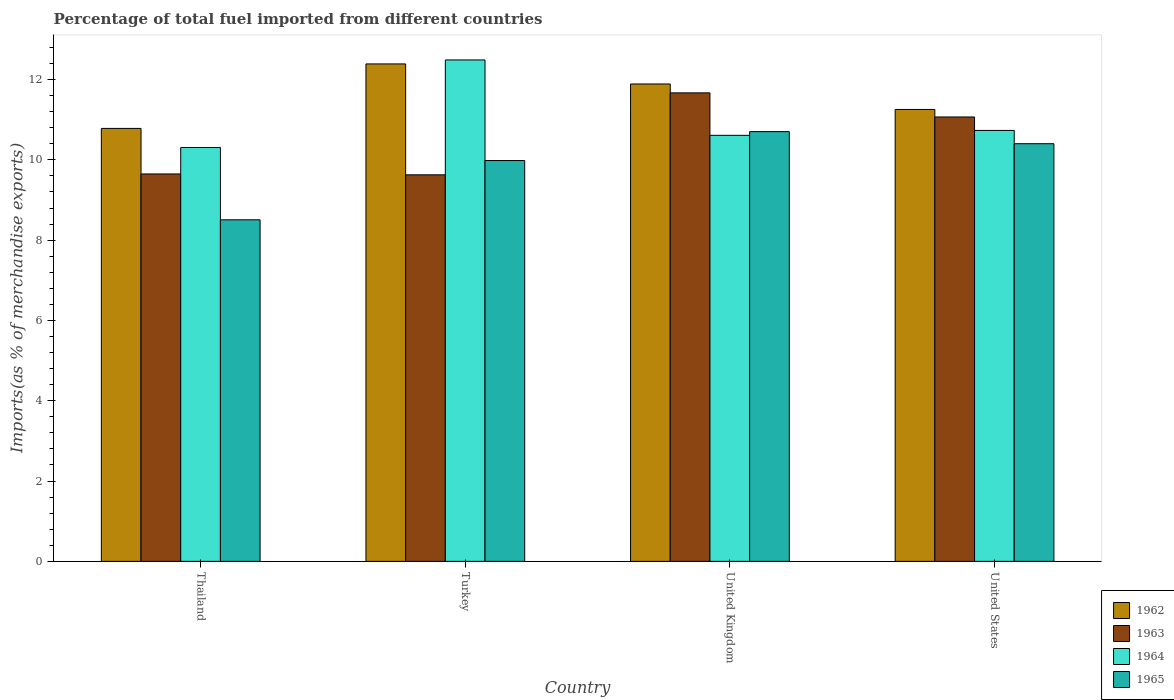How many different coloured bars are there?
Offer a terse response. 4. How many groups of bars are there?
Provide a succinct answer. 4. Are the number of bars on each tick of the X-axis equal?
Provide a succinct answer. Yes. How many bars are there on the 3rd tick from the right?
Offer a very short reply. 4. What is the label of the 1st group of bars from the left?
Keep it short and to the point. Thailand. In how many cases, is the number of bars for a given country not equal to the number of legend labels?
Provide a short and direct response. 0. What is the percentage of imports to different countries in 1965 in Turkey?
Offer a terse response. 9.98. Across all countries, what is the maximum percentage of imports to different countries in 1963?
Your answer should be compact. 11.67. Across all countries, what is the minimum percentage of imports to different countries in 1963?
Your answer should be very brief. 9.63. In which country was the percentage of imports to different countries in 1963 maximum?
Your answer should be compact. United Kingdom. In which country was the percentage of imports to different countries in 1963 minimum?
Your answer should be very brief. Turkey. What is the total percentage of imports to different countries in 1964 in the graph?
Your answer should be very brief. 44.14. What is the difference between the percentage of imports to different countries in 1965 in United Kingdom and that in United States?
Provide a short and direct response. 0.3. What is the difference between the percentage of imports to different countries in 1964 in United Kingdom and the percentage of imports to different countries in 1962 in United States?
Offer a terse response. -0.64. What is the average percentage of imports to different countries in 1964 per country?
Your answer should be very brief. 11.03. What is the difference between the percentage of imports to different countries of/in 1965 and percentage of imports to different countries of/in 1963 in United States?
Give a very brief answer. -0.67. In how many countries, is the percentage of imports to different countries in 1965 greater than 11.6 %?
Ensure brevity in your answer.  0. What is the ratio of the percentage of imports to different countries in 1964 in Thailand to that in United Kingdom?
Offer a very short reply. 0.97. Is the percentage of imports to different countries in 1965 in Thailand less than that in United States?
Ensure brevity in your answer.  Yes. Is the difference between the percentage of imports to different countries in 1965 in Thailand and Turkey greater than the difference between the percentage of imports to different countries in 1963 in Thailand and Turkey?
Give a very brief answer. No. What is the difference between the highest and the second highest percentage of imports to different countries in 1963?
Give a very brief answer. 1.42. What is the difference between the highest and the lowest percentage of imports to different countries in 1964?
Ensure brevity in your answer.  2.18. Is the sum of the percentage of imports to different countries in 1962 in United Kingdom and United States greater than the maximum percentage of imports to different countries in 1964 across all countries?
Offer a terse response. Yes. What does the 2nd bar from the right in United States represents?
Make the answer very short. 1964. Is it the case that in every country, the sum of the percentage of imports to different countries in 1964 and percentage of imports to different countries in 1963 is greater than the percentage of imports to different countries in 1965?
Keep it short and to the point. Yes. Are all the bars in the graph horizontal?
Make the answer very short. No. What is the difference between two consecutive major ticks on the Y-axis?
Your answer should be compact. 2. Are the values on the major ticks of Y-axis written in scientific E-notation?
Your answer should be compact. No. Where does the legend appear in the graph?
Provide a short and direct response. Bottom right. What is the title of the graph?
Your answer should be very brief. Percentage of total fuel imported from different countries. What is the label or title of the Y-axis?
Offer a terse response. Imports(as % of merchandise exports). What is the Imports(as % of merchandise exports) in 1962 in Thailand?
Offer a terse response. 10.78. What is the Imports(as % of merchandise exports) of 1963 in Thailand?
Your answer should be very brief. 9.65. What is the Imports(as % of merchandise exports) in 1964 in Thailand?
Give a very brief answer. 10.31. What is the Imports(as % of merchandise exports) in 1965 in Thailand?
Keep it short and to the point. 8.51. What is the Imports(as % of merchandise exports) in 1962 in Turkey?
Provide a short and direct response. 12.39. What is the Imports(as % of merchandise exports) in 1963 in Turkey?
Offer a very short reply. 9.63. What is the Imports(as % of merchandise exports) of 1964 in Turkey?
Your response must be concise. 12.49. What is the Imports(as % of merchandise exports) in 1965 in Turkey?
Provide a short and direct response. 9.98. What is the Imports(as % of merchandise exports) in 1962 in United Kingdom?
Offer a terse response. 11.89. What is the Imports(as % of merchandise exports) in 1963 in United Kingdom?
Offer a very short reply. 11.67. What is the Imports(as % of merchandise exports) in 1964 in United Kingdom?
Offer a terse response. 10.61. What is the Imports(as % of merchandise exports) in 1965 in United Kingdom?
Your answer should be very brief. 10.7. What is the Imports(as % of merchandise exports) in 1962 in United States?
Your answer should be very brief. 11.25. What is the Imports(as % of merchandise exports) of 1963 in United States?
Provide a succinct answer. 11.07. What is the Imports(as % of merchandise exports) in 1964 in United States?
Offer a very short reply. 10.73. What is the Imports(as % of merchandise exports) in 1965 in United States?
Your answer should be very brief. 10.4. Across all countries, what is the maximum Imports(as % of merchandise exports) of 1962?
Give a very brief answer. 12.39. Across all countries, what is the maximum Imports(as % of merchandise exports) of 1963?
Provide a succinct answer. 11.67. Across all countries, what is the maximum Imports(as % of merchandise exports) in 1964?
Your response must be concise. 12.49. Across all countries, what is the maximum Imports(as % of merchandise exports) in 1965?
Ensure brevity in your answer.  10.7. Across all countries, what is the minimum Imports(as % of merchandise exports) of 1962?
Offer a very short reply. 10.78. Across all countries, what is the minimum Imports(as % of merchandise exports) in 1963?
Keep it short and to the point. 9.63. Across all countries, what is the minimum Imports(as % of merchandise exports) of 1964?
Your answer should be compact. 10.31. Across all countries, what is the minimum Imports(as % of merchandise exports) of 1965?
Keep it short and to the point. 8.51. What is the total Imports(as % of merchandise exports) of 1962 in the graph?
Provide a succinct answer. 46.31. What is the total Imports(as % of merchandise exports) in 1963 in the graph?
Offer a very short reply. 42.01. What is the total Imports(as % of merchandise exports) of 1964 in the graph?
Provide a succinct answer. 44.14. What is the total Imports(as % of merchandise exports) of 1965 in the graph?
Keep it short and to the point. 39.59. What is the difference between the Imports(as % of merchandise exports) in 1962 in Thailand and that in Turkey?
Offer a terse response. -1.61. What is the difference between the Imports(as % of merchandise exports) of 1963 in Thailand and that in Turkey?
Offer a terse response. 0.02. What is the difference between the Imports(as % of merchandise exports) in 1964 in Thailand and that in Turkey?
Give a very brief answer. -2.18. What is the difference between the Imports(as % of merchandise exports) in 1965 in Thailand and that in Turkey?
Provide a short and direct response. -1.48. What is the difference between the Imports(as % of merchandise exports) of 1962 in Thailand and that in United Kingdom?
Your answer should be compact. -1.11. What is the difference between the Imports(as % of merchandise exports) of 1963 in Thailand and that in United Kingdom?
Provide a short and direct response. -2.02. What is the difference between the Imports(as % of merchandise exports) of 1964 in Thailand and that in United Kingdom?
Ensure brevity in your answer.  -0.3. What is the difference between the Imports(as % of merchandise exports) in 1965 in Thailand and that in United Kingdom?
Ensure brevity in your answer.  -2.2. What is the difference between the Imports(as % of merchandise exports) in 1962 in Thailand and that in United States?
Your answer should be very brief. -0.47. What is the difference between the Imports(as % of merchandise exports) of 1963 in Thailand and that in United States?
Provide a succinct answer. -1.42. What is the difference between the Imports(as % of merchandise exports) of 1964 in Thailand and that in United States?
Offer a terse response. -0.42. What is the difference between the Imports(as % of merchandise exports) in 1965 in Thailand and that in United States?
Your answer should be compact. -1.9. What is the difference between the Imports(as % of merchandise exports) of 1962 in Turkey and that in United Kingdom?
Provide a succinct answer. 0.5. What is the difference between the Imports(as % of merchandise exports) in 1963 in Turkey and that in United Kingdom?
Ensure brevity in your answer.  -2.04. What is the difference between the Imports(as % of merchandise exports) in 1964 in Turkey and that in United Kingdom?
Provide a short and direct response. 1.88. What is the difference between the Imports(as % of merchandise exports) of 1965 in Turkey and that in United Kingdom?
Offer a very short reply. -0.72. What is the difference between the Imports(as % of merchandise exports) of 1962 in Turkey and that in United States?
Offer a terse response. 1.13. What is the difference between the Imports(as % of merchandise exports) of 1963 in Turkey and that in United States?
Offer a terse response. -1.44. What is the difference between the Imports(as % of merchandise exports) in 1964 in Turkey and that in United States?
Provide a succinct answer. 1.76. What is the difference between the Imports(as % of merchandise exports) of 1965 in Turkey and that in United States?
Keep it short and to the point. -0.42. What is the difference between the Imports(as % of merchandise exports) of 1962 in United Kingdom and that in United States?
Ensure brevity in your answer.  0.63. What is the difference between the Imports(as % of merchandise exports) of 1963 in United Kingdom and that in United States?
Give a very brief answer. 0.6. What is the difference between the Imports(as % of merchandise exports) in 1964 in United Kingdom and that in United States?
Your response must be concise. -0.12. What is the difference between the Imports(as % of merchandise exports) in 1965 in United Kingdom and that in United States?
Keep it short and to the point. 0.3. What is the difference between the Imports(as % of merchandise exports) in 1962 in Thailand and the Imports(as % of merchandise exports) in 1963 in Turkey?
Offer a very short reply. 1.16. What is the difference between the Imports(as % of merchandise exports) in 1962 in Thailand and the Imports(as % of merchandise exports) in 1964 in Turkey?
Provide a short and direct response. -1.71. What is the difference between the Imports(as % of merchandise exports) in 1963 in Thailand and the Imports(as % of merchandise exports) in 1964 in Turkey?
Your response must be concise. -2.84. What is the difference between the Imports(as % of merchandise exports) in 1963 in Thailand and the Imports(as % of merchandise exports) in 1965 in Turkey?
Provide a succinct answer. -0.33. What is the difference between the Imports(as % of merchandise exports) in 1964 in Thailand and the Imports(as % of merchandise exports) in 1965 in Turkey?
Your answer should be very brief. 0.32. What is the difference between the Imports(as % of merchandise exports) in 1962 in Thailand and the Imports(as % of merchandise exports) in 1963 in United Kingdom?
Offer a terse response. -0.89. What is the difference between the Imports(as % of merchandise exports) of 1962 in Thailand and the Imports(as % of merchandise exports) of 1964 in United Kingdom?
Your answer should be compact. 0.17. What is the difference between the Imports(as % of merchandise exports) of 1962 in Thailand and the Imports(as % of merchandise exports) of 1965 in United Kingdom?
Make the answer very short. 0.08. What is the difference between the Imports(as % of merchandise exports) of 1963 in Thailand and the Imports(as % of merchandise exports) of 1964 in United Kingdom?
Offer a terse response. -0.96. What is the difference between the Imports(as % of merchandise exports) in 1963 in Thailand and the Imports(as % of merchandise exports) in 1965 in United Kingdom?
Your response must be concise. -1.05. What is the difference between the Imports(as % of merchandise exports) of 1964 in Thailand and the Imports(as % of merchandise exports) of 1965 in United Kingdom?
Your answer should be compact. -0.4. What is the difference between the Imports(as % of merchandise exports) of 1962 in Thailand and the Imports(as % of merchandise exports) of 1963 in United States?
Provide a succinct answer. -0.28. What is the difference between the Imports(as % of merchandise exports) of 1962 in Thailand and the Imports(as % of merchandise exports) of 1964 in United States?
Give a very brief answer. 0.05. What is the difference between the Imports(as % of merchandise exports) in 1962 in Thailand and the Imports(as % of merchandise exports) in 1965 in United States?
Keep it short and to the point. 0.38. What is the difference between the Imports(as % of merchandise exports) of 1963 in Thailand and the Imports(as % of merchandise exports) of 1964 in United States?
Offer a terse response. -1.08. What is the difference between the Imports(as % of merchandise exports) in 1963 in Thailand and the Imports(as % of merchandise exports) in 1965 in United States?
Keep it short and to the point. -0.75. What is the difference between the Imports(as % of merchandise exports) in 1964 in Thailand and the Imports(as % of merchandise exports) in 1965 in United States?
Your response must be concise. -0.09. What is the difference between the Imports(as % of merchandise exports) of 1962 in Turkey and the Imports(as % of merchandise exports) of 1963 in United Kingdom?
Your answer should be very brief. 0.72. What is the difference between the Imports(as % of merchandise exports) in 1962 in Turkey and the Imports(as % of merchandise exports) in 1964 in United Kingdom?
Your answer should be very brief. 1.78. What is the difference between the Imports(as % of merchandise exports) of 1962 in Turkey and the Imports(as % of merchandise exports) of 1965 in United Kingdom?
Provide a succinct answer. 1.69. What is the difference between the Imports(as % of merchandise exports) of 1963 in Turkey and the Imports(as % of merchandise exports) of 1964 in United Kingdom?
Provide a short and direct response. -0.98. What is the difference between the Imports(as % of merchandise exports) in 1963 in Turkey and the Imports(as % of merchandise exports) in 1965 in United Kingdom?
Offer a very short reply. -1.08. What is the difference between the Imports(as % of merchandise exports) in 1964 in Turkey and the Imports(as % of merchandise exports) in 1965 in United Kingdom?
Provide a succinct answer. 1.78. What is the difference between the Imports(as % of merchandise exports) of 1962 in Turkey and the Imports(as % of merchandise exports) of 1963 in United States?
Your answer should be compact. 1.32. What is the difference between the Imports(as % of merchandise exports) of 1962 in Turkey and the Imports(as % of merchandise exports) of 1964 in United States?
Ensure brevity in your answer.  1.66. What is the difference between the Imports(as % of merchandise exports) in 1962 in Turkey and the Imports(as % of merchandise exports) in 1965 in United States?
Make the answer very short. 1.99. What is the difference between the Imports(as % of merchandise exports) in 1963 in Turkey and the Imports(as % of merchandise exports) in 1964 in United States?
Your response must be concise. -1.11. What is the difference between the Imports(as % of merchandise exports) of 1963 in Turkey and the Imports(as % of merchandise exports) of 1965 in United States?
Keep it short and to the point. -0.77. What is the difference between the Imports(as % of merchandise exports) of 1964 in Turkey and the Imports(as % of merchandise exports) of 1965 in United States?
Keep it short and to the point. 2.09. What is the difference between the Imports(as % of merchandise exports) of 1962 in United Kingdom and the Imports(as % of merchandise exports) of 1963 in United States?
Your response must be concise. 0.82. What is the difference between the Imports(as % of merchandise exports) of 1962 in United Kingdom and the Imports(as % of merchandise exports) of 1964 in United States?
Offer a very short reply. 1.16. What is the difference between the Imports(as % of merchandise exports) in 1962 in United Kingdom and the Imports(as % of merchandise exports) in 1965 in United States?
Provide a short and direct response. 1.49. What is the difference between the Imports(as % of merchandise exports) of 1963 in United Kingdom and the Imports(as % of merchandise exports) of 1964 in United States?
Ensure brevity in your answer.  0.94. What is the difference between the Imports(as % of merchandise exports) of 1963 in United Kingdom and the Imports(as % of merchandise exports) of 1965 in United States?
Offer a terse response. 1.27. What is the difference between the Imports(as % of merchandise exports) in 1964 in United Kingdom and the Imports(as % of merchandise exports) in 1965 in United States?
Offer a very short reply. 0.21. What is the average Imports(as % of merchandise exports) of 1962 per country?
Keep it short and to the point. 11.58. What is the average Imports(as % of merchandise exports) of 1963 per country?
Provide a succinct answer. 10.5. What is the average Imports(as % of merchandise exports) in 1964 per country?
Keep it short and to the point. 11.03. What is the average Imports(as % of merchandise exports) in 1965 per country?
Offer a terse response. 9.9. What is the difference between the Imports(as % of merchandise exports) of 1962 and Imports(as % of merchandise exports) of 1963 in Thailand?
Your answer should be compact. 1.13. What is the difference between the Imports(as % of merchandise exports) in 1962 and Imports(as % of merchandise exports) in 1964 in Thailand?
Your answer should be very brief. 0.48. What is the difference between the Imports(as % of merchandise exports) of 1962 and Imports(as % of merchandise exports) of 1965 in Thailand?
Give a very brief answer. 2.28. What is the difference between the Imports(as % of merchandise exports) in 1963 and Imports(as % of merchandise exports) in 1964 in Thailand?
Make the answer very short. -0.66. What is the difference between the Imports(as % of merchandise exports) of 1963 and Imports(as % of merchandise exports) of 1965 in Thailand?
Keep it short and to the point. 1.14. What is the difference between the Imports(as % of merchandise exports) of 1964 and Imports(as % of merchandise exports) of 1965 in Thailand?
Your answer should be compact. 1.8. What is the difference between the Imports(as % of merchandise exports) in 1962 and Imports(as % of merchandise exports) in 1963 in Turkey?
Provide a succinct answer. 2.76. What is the difference between the Imports(as % of merchandise exports) of 1962 and Imports(as % of merchandise exports) of 1964 in Turkey?
Provide a succinct answer. -0.1. What is the difference between the Imports(as % of merchandise exports) in 1962 and Imports(as % of merchandise exports) in 1965 in Turkey?
Your response must be concise. 2.41. What is the difference between the Imports(as % of merchandise exports) of 1963 and Imports(as % of merchandise exports) of 1964 in Turkey?
Keep it short and to the point. -2.86. What is the difference between the Imports(as % of merchandise exports) in 1963 and Imports(as % of merchandise exports) in 1965 in Turkey?
Offer a terse response. -0.36. What is the difference between the Imports(as % of merchandise exports) of 1964 and Imports(as % of merchandise exports) of 1965 in Turkey?
Provide a succinct answer. 2.51. What is the difference between the Imports(as % of merchandise exports) of 1962 and Imports(as % of merchandise exports) of 1963 in United Kingdom?
Your answer should be very brief. 0.22. What is the difference between the Imports(as % of merchandise exports) of 1962 and Imports(as % of merchandise exports) of 1964 in United Kingdom?
Offer a very short reply. 1.28. What is the difference between the Imports(as % of merchandise exports) in 1962 and Imports(as % of merchandise exports) in 1965 in United Kingdom?
Provide a succinct answer. 1.19. What is the difference between the Imports(as % of merchandise exports) of 1963 and Imports(as % of merchandise exports) of 1964 in United Kingdom?
Offer a very short reply. 1.06. What is the difference between the Imports(as % of merchandise exports) of 1963 and Imports(as % of merchandise exports) of 1965 in United Kingdom?
Your response must be concise. 0.96. What is the difference between the Imports(as % of merchandise exports) in 1964 and Imports(as % of merchandise exports) in 1965 in United Kingdom?
Your answer should be very brief. -0.09. What is the difference between the Imports(as % of merchandise exports) in 1962 and Imports(as % of merchandise exports) in 1963 in United States?
Provide a short and direct response. 0.19. What is the difference between the Imports(as % of merchandise exports) of 1962 and Imports(as % of merchandise exports) of 1964 in United States?
Your response must be concise. 0.52. What is the difference between the Imports(as % of merchandise exports) of 1962 and Imports(as % of merchandise exports) of 1965 in United States?
Give a very brief answer. 0.85. What is the difference between the Imports(as % of merchandise exports) in 1963 and Imports(as % of merchandise exports) in 1964 in United States?
Offer a very short reply. 0.33. What is the difference between the Imports(as % of merchandise exports) of 1963 and Imports(as % of merchandise exports) of 1965 in United States?
Keep it short and to the point. 0.67. What is the difference between the Imports(as % of merchandise exports) of 1964 and Imports(as % of merchandise exports) of 1965 in United States?
Provide a short and direct response. 0.33. What is the ratio of the Imports(as % of merchandise exports) of 1962 in Thailand to that in Turkey?
Your answer should be compact. 0.87. What is the ratio of the Imports(as % of merchandise exports) in 1963 in Thailand to that in Turkey?
Your answer should be very brief. 1. What is the ratio of the Imports(as % of merchandise exports) in 1964 in Thailand to that in Turkey?
Ensure brevity in your answer.  0.83. What is the ratio of the Imports(as % of merchandise exports) in 1965 in Thailand to that in Turkey?
Give a very brief answer. 0.85. What is the ratio of the Imports(as % of merchandise exports) in 1962 in Thailand to that in United Kingdom?
Offer a very short reply. 0.91. What is the ratio of the Imports(as % of merchandise exports) in 1963 in Thailand to that in United Kingdom?
Keep it short and to the point. 0.83. What is the ratio of the Imports(as % of merchandise exports) in 1964 in Thailand to that in United Kingdom?
Your answer should be very brief. 0.97. What is the ratio of the Imports(as % of merchandise exports) of 1965 in Thailand to that in United Kingdom?
Provide a succinct answer. 0.79. What is the ratio of the Imports(as % of merchandise exports) of 1962 in Thailand to that in United States?
Provide a succinct answer. 0.96. What is the ratio of the Imports(as % of merchandise exports) in 1963 in Thailand to that in United States?
Provide a succinct answer. 0.87. What is the ratio of the Imports(as % of merchandise exports) of 1964 in Thailand to that in United States?
Ensure brevity in your answer.  0.96. What is the ratio of the Imports(as % of merchandise exports) in 1965 in Thailand to that in United States?
Offer a very short reply. 0.82. What is the ratio of the Imports(as % of merchandise exports) in 1962 in Turkey to that in United Kingdom?
Provide a succinct answer. 1.04. What is the ratio of the Imports(as % of merchandise exports) of 1963 in Turkey to that in United Kingdom?
Give a very brief answer. 0.83. What is the ratio of the Imports(as % of merchandise exports) of 1964 in Turkey to that in United Kingdom?
Your answer should be very brief. 1.18. What is the ratio of the Imports(as % of merchandise exports) of 1965 in Turkey to that in United Kingdom?
Offer a terse response. 0.93. What is the ratio of the Imports(as % of merchandise exports) in 1962 in Turkey to that in United States?
Ensure brevity in your answer.  1.1. What is the ratio of the Imports(as % of merchandise exports) of 1963 in Turkey to that in United States?
Your response must be concise. 0.87. What is the ratio of the Imports(as % of merchandise exports) of 1964 in Turkey to that in United States?
Offer a terse response. 1.16. What is the ratio of the Imports(as % of merchandise exports) of 1965 in Turkey to that in United States?
Offer a terse response. 0.96. What is the ratio of the Imports(as % of merchandise exports) in 1962 in United Kingdom to that in United States?
Offer a very short reply. 1.06. What is the ratio of the Imports(as % of merchandise exports) of 1963 in United Kingdom to that in United States?
Your answer should be compact. 1.05. What is the ratio of the Imports(as % of merchandise exports) of 1964 in United Kingdom to that in United States?
Give a very brief answer. 0.99. What is the ratio of the Imports(as % of merchandise exports) in 1965 in United Kingdom to that in United States?
Offer a terse response. 1.03. What is the difference between the highest and the second highest Imports(as % of merchandise exports) of 1962?
Offer a terse response. 0.5. What is the difference between the highest and the second highest Imports(as % of merchandise exports) in 1963?
Ensure brevity in your answer.  0.6. What is the difference between the highest and the second highest Imports(as % of merchandise exports) in 1964?
Make the answer very short. 1.76. What is the difference between the highest and the second highest Imports(as % of merchandise exports) of 1965?
Make the answer very short. 0.3. What is the difference between the highest and the lowest Imports(as % of merchandise exports) of 1962?
Your answer should be compact. 1.61. What is the difference between the highest and the lowest Imports(as % of merchandise exports) of 1963?
Offer a very short reply. 2.04. What is the difference between the highest and the lowest Imports(as % of merchandise exports) in 1964?
Your answer should be compact. 2.18. What is the difference between the highest and the lowest Imports(as % of merchandise exports) of 1965?
Make the answer very short. 2.2. 